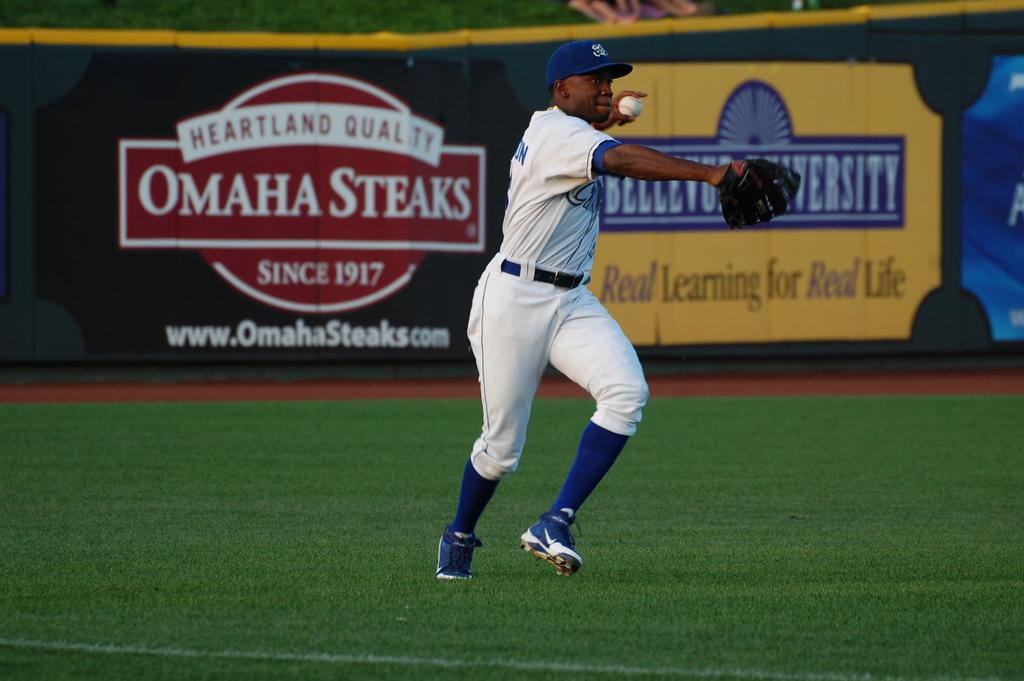What is the website address on the steak sign?
Offer a very short reply. Www.omahasteaks.com. 